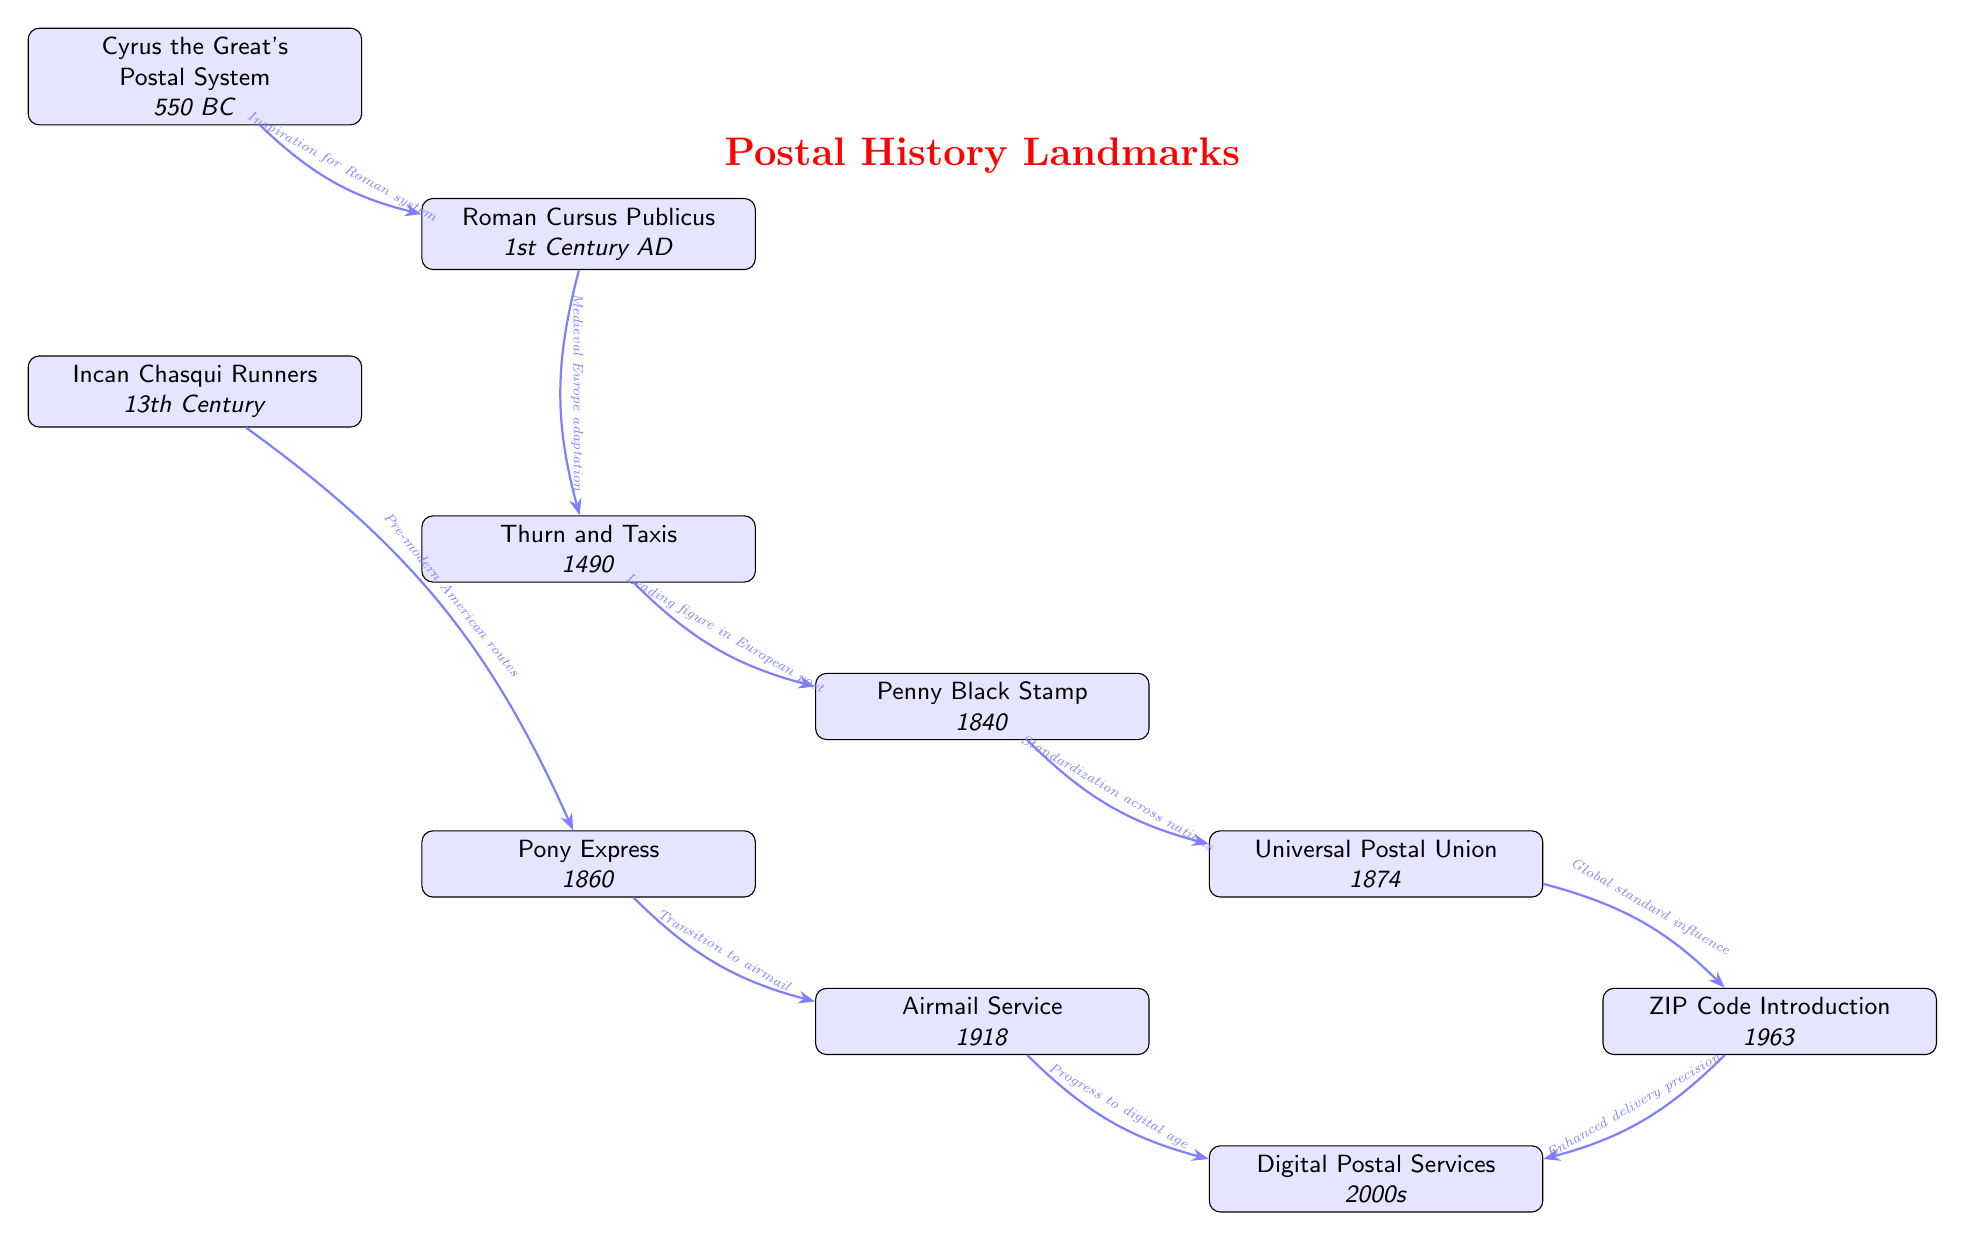What is the earliest postal system mentioned in the diagram? The diagram lists Cyrus the Great's Postal System at the topmost node, which is the first event in the timeline. Therefore, this postal system is the earliest one mentioned.
Answer: Cyrus the Great's Postal System Which postal service was introduced in 1963? The diagram shows the node labeled "ZIP Code Introduction" positioned at the bottom left. This directly indicates that the postal service introduced in 1963 is the ZIP Code system.
Answer: ZIP Code Introduction How many significant events in postal history are depicted in the diagram? By counting the nodes in the diagram, there are a total of ten events listed, each representing a key milestone in postal history.
Answer: 10 What milestone followed the Penny Black Stamp? Observing the direct connection in the diagram, the Penny Black Stamp is followed by the Pony Express (1860), as illustrated with an arrow leading to that event.
Answer: Pony Express Which historical figure is associated with the development of the Postal Service in Europe? The node labeled "Thurn and Taxis" mentions that he was a leading figure in the European postal system. Therefore, he is the historical figure indicated in the diagram.
Answer: Thurn and Taxis What type of innovation does the node "Digital Postal Services" represent? This node signifies advancement in postal communication technologies occurring in the 2000s. Thus, it represents digital innovations in postal services.
Answer: Digital innovations How many arrows connect the events representing the evolution of postal services? Upon analyzing the diagram, there are nine arrows indicating connections between different events. Hence, the total number of arrows present is nine.
Answer: 9 What postal service is linked to the standardization across nations? The diagram draws an arrow from "Penny Black Stamp" to "Universal Postal Union," indicating that the Universal Postal Union is the service linked to standardization across nations as a result of the Penny Black Stamp.
Answer: Universal Postal Union What was the transition mentioned in the connection from Pony Express to Airmail Service? The arrow from the Pony Express to Airmail Service notes "Transition to airmail," indicating that this transition marks the shift from land-based to air-based postal delivery systems during that period.
Answer: Transition to airmail 